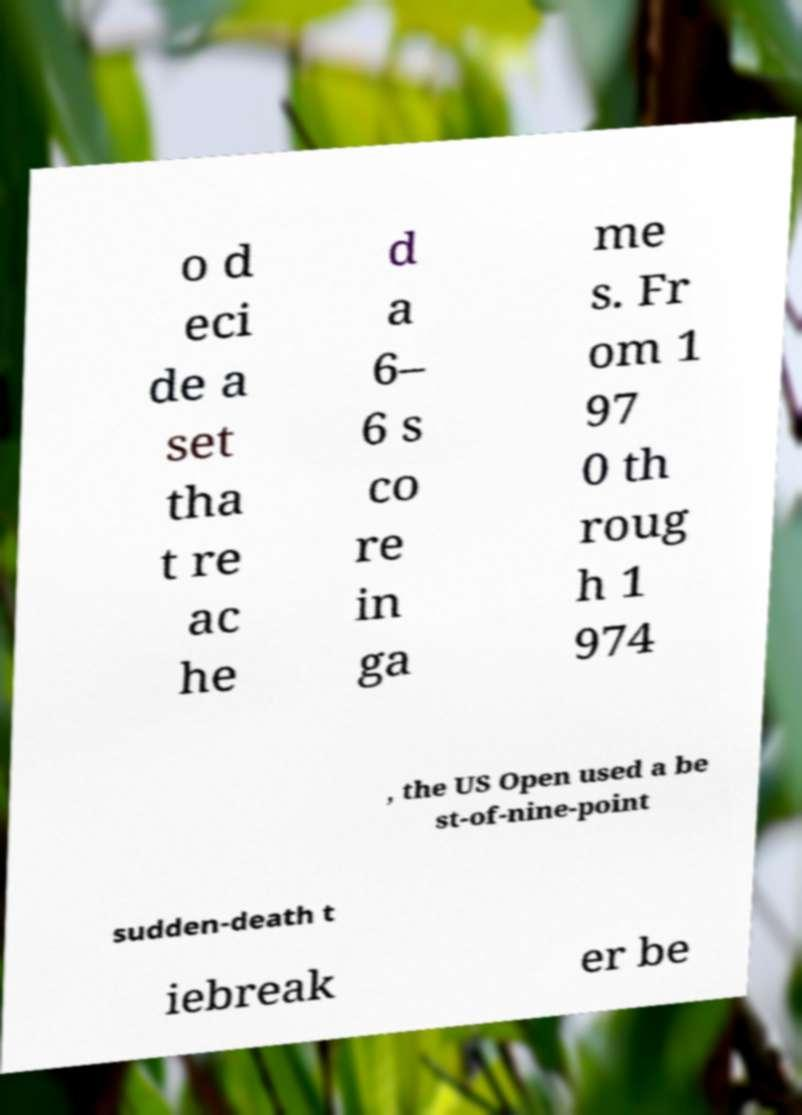For documentation purposes, I need the text within this image transcribed. Could you provide that? o d eci de a set tha t re ac he d a 6– 6 s co re in ga me s. Fr om 1 97 0 th roug h 1 974 , the US Open used a be st-of-nine-point sudden-death t iebreak er be 